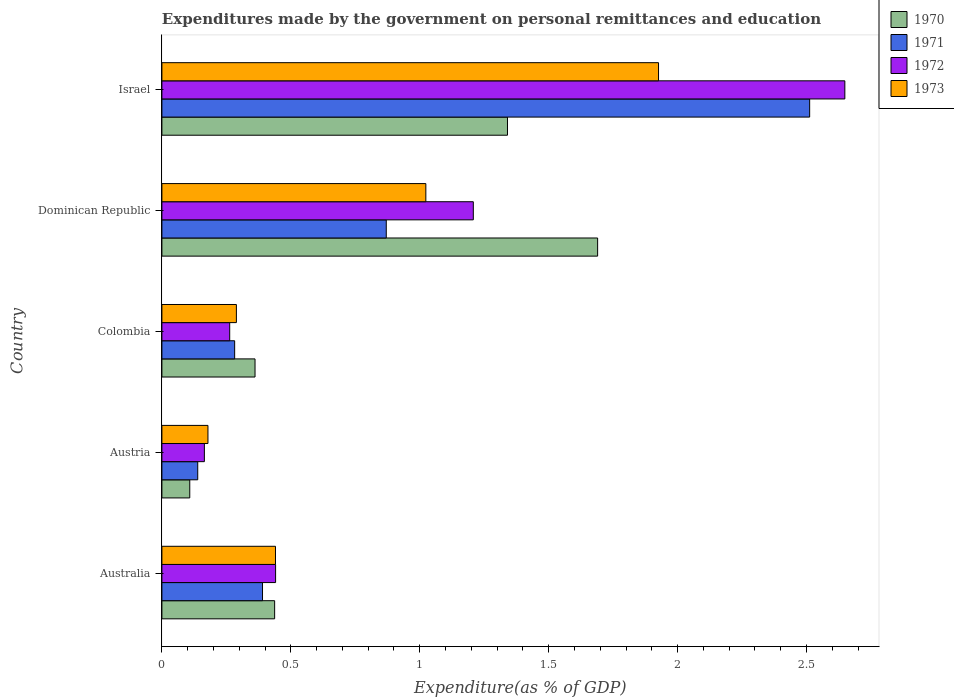How many different coloured bars are there?
Your answer should be very brief. 4. How many groups of bars are there?
Offer a terse response. 5. In how many cases, is the number of bars for a given country not equal to the number of legend labels?
Offer a very short reply. 0. What is the expenditures made by the government on personal remittances and education in 1971 in Australia?
Offer a very short reply. 0.39. Across all countries, what is the maximum expenditures made by the government on personal remittances and education in 1973?
Provide a succinct answer. 1.93. Across all countries, what is the minimum expenditures made by the government on personal remittances and education in 1970?
Give a very brief answer. 0.11. In which country was the expenditures made by the government on personal remittances and education in 1970 maximum?
Give a very brief answer. Dominican Republic. In which country was the expenditures made by the government on personal remittances and education in 1973 minimum?
Offer a terse response. Austria. What is the total expenditures made by the government on personal remittances and education in 1970 in the graph?
Ensure brevity in your answer.  3.94. What is the difference between the expenditures made by the government on personal remittances and education in 1972 in Colombia and that in Israel?
Give a very brief answer. -2.39. What is the difference between the expenditures made by the government on personal remittances and education in 1973 in Colombia and the expenditures made by the government on personal remittances and education in 1970 in Israel?
Your response must be concise. -1.05. What is the average expenditures made by the government on personal remittances and education in 1970 per country?
Offer a terse response. 0.79. What is the difference between the expenditures made by the government on personal remittances and education in 1972 and expenditures made by the government on personal remittances and education in 1973 in Israel?
Offer a very short reply. 0.72. In how many countries, is the expenditures made by the government on personal remittances and education in 1972 greater than 0.2 %?
Provide a short and direct response. 4. What is the ratio of the expenditures made by the government on personal remittances and education in 1971 in Australia to that in Israel?
Offer a very short reply. 0.16. Is the expenditures made by the government on personal remittances and education in 1971 in Australia less than that in Dominican Republic?
Keep it short and to the point. Yes. Is the difference between the expenditures made by the government on personal remittances and education in 1972 in Australia and Colombia greater than the difference between the expenditures made by the government on personal remittances and education in 1973 in Australia and Colombia?
Your response must be concise. Yes. What is the difference between the highest and the second highest expenditures made by the government on personal remittances and education in 1973?
Offer a terse response. 0.9. What is the difference between the highest and the lowest expenditures made by the government on personal remittances and education in 1973?
Offer a very short reply. 1.75. In how many countries, is the expenditures made by the government on personal remittances and education in 1970 greater than the average expenditures made by the government on personal remittances and education in 1970 taken over all countries?
Provide a succinct answer. 2. Is it the case that in every country, the sum of the expenditures made by the government on personal remittances and education in 1973 and expenditures made by the government on personal remittances and education in 1970 is greater than the sum of expenditures made by the government on personal remittances and education in 1972 and expenditures made by the government on personal remittances and education in 1971?
Your response must be concise. No. What does the 3rd bar from the bottom in Dominican Republic represents?
Offer a terse response. 1972. Is it the case that in every country, the sum of the expenditures made by the government on personal remittances and education in 1973 and expenditures made by the government on personal remittances and education in 1972 is greater than the expenditures made by the government on personal remittances and education in 1971?
Keep it short and to the point. Yes. Are the values on the major ticks of X-axis written in scientific E-notation?
Your answer should be compact. No. What is the title of the graph?
Your answer should be compact. Expenditures made by the government on personal remittances and education. Does "1996" appear as one of the legend labels in the graph?
Your answer should be very brief. No. What is the label or title of the X-axis?
Your answer should be very brief. Expenditure(as % of GDP). What is the label or title of the Y-axis?
Provide a short and direct response. Country. What is the Expenditure(as % of GDP) in 1970 in Australia?
Your answer should be compact. 0.44. What is the Expenditure(as % of GDP) in 1971 in Australia?
Offer a terse response. 0.39. What is the Expenditure(as % of GDP) of 1972 in Australia?
Provide a succinct answer. 0.44. What is the Expenditure(as % of GDP) in 1973 in Australia?
Ensure brevity in your answer.  0.44. What is the Expenditure(as % of GDP) of 1970 in Austria?
Keep it short and to the point. 0.11. What is the Expenditure(as % of GDP) of 1971 in Austria?
Offer a very short reply. 0.14. What is the Expenditure(as % of GDP) in 1972 in Austria?
Ensure brevity in your answer.  0.16. What is the Expenditure(as % of GDP) of 1973 in Austria?
Your response must be concise. 0.18. What is the Expenditure(as % of GDP) in 1970 in Colombia?
Provide a short and direct response. 0.36. What is the Expenditure(as % of GDP) in 1971 in Colombia?
Provide a succinct answer. 0.28. What is the Expenditure(as % of GDP) in 1972 in Colombia?
Your answer should be compact. 0.26. What is the Expenditure(as % of GDP) in 1973 in Colombia?
Offer a very short reply. 0.29. What is the Expenditure(as % of GDP) in 1970 in Dominican Republic?
Your answer should be compact. 1.69. What is the Expenditure(as % of GDP) of 1971 in Dominican Republic?
Make the answer very short. 0.87. What is the Expenditure(as % of GDP) in 1972 in Dominican Republic?
Keep it short and to the point. 1.21. What is the Expenditure(as % of GDP) in 1973 in Dominican Republic?
Keep it short and to the point. 1.02. What is the Expenditure(as % of GDP) of 1970 in Israel?
Keep it short and to the point. 1.34. What is the Expenditure(as % of GDP) in 1971 in Israel?
Give a very brief answer. 2.51. What is the Expenditure(as % of GDP) of 1972 in Israel?
Your answer should be very brief. 2.65. What is the Expenditure(as % of GDP) in 1973 in Israel?
Your answer should be very brief. 1.93. Across all countries, what is the maximum Expenditure(as % of GDP) of 1970?
Keep it short and to the point. 1.69. Across all countries, what is the maximum Expenditure(as % of GDP) of 1971?
Give a very brief answer. 2.51. Across all countries, what is the maximum Expenditure(as % of GDP) in 1972?
Offer a very short reply. 2.65. Across all countries, what is the maximum Expenditure(as % of GDP) of 1973?
Ensure brevity in your answer.  1.93. Across all countries, what is the minimum Expenditure(as % of GDP) in 1970?
Offer a very short reply. 0.11. Across all countries, what is the minimum Expenditure(as % of GDP) of 1971?
Offer a terse response. 0.14. Across all countries, what is the minimum Expenditure(as % of GDP) in 1972?
Offer a very short reply. 0.16. Across all countries, what is the minimum Expenditure(as % of GDP) of 1973?
Offer a terse response. 0.18. What is the total Expenditure(as % of GDP) of 1970 in the graph?
Make the answer very short. 3.94. What is the total Expenditure(as % of GDP) in 1971 in the graph?
Your answer should be very brief. 4.19. What is the total Expenditure(as % of GDP) of 1972 in the graph?
Give a very brief answer. 4.72. What is the total Expenditure(as % of GDP) of 1973 in the graph?
Keep it short and to the point. 3.86. What is the difference between the Expenditure(as % of GDP) of 1970 in Australia and that in Austria?
Provide a succinct answer. 0.33. What is the difference between the Expenditure(as % of GDP) in 1971 in Australia and that in Austria?
Offer a terse response. 0.25. What is the difference between the Expenditure(as % of GDP) in 1972 in Australia and that in Austria?
Ensure brevity in your answer.  0.28. What is the difference between the Expenditure(as % of GDP) in 1973 in Australia and that in Austria?
Your answer should be compact. 0.26. What is the difference between the Expenditure(as % of GDP) in 1970 in Australia and that in Colombia?
Make the answer very short. 0.08. What is the difference between the Expenditure(as % of GDP) in 1971 in Australia and that in Colombia?
Ensure brevity in your answer.  0.11. What is the difference between the Expenditure(as % of GDP) in 1972 in Australia and that in Colombia?
Make the answer very short. 0.18. What is the difference between the Expenditure(as % of GDP) of 1973 in Australia and that in Colombia?
Ensure brevity in your answer.  0.15. What is the difference between the Expenditure(as % of GDP) in 1970 in Australia and that in Dominican Republic?
Provide a succinct answer. -1.25. What is the difference between the Expenditure(as % of GDP) of 1971 in Australia and that in Dominican Republic?
Keep it short and to the point. -0.48. What is the difference between the Expenditure(as % of GDP) in 1972 in Australia and that in Dominican Republic?
Provide a succinct answer. -0.77. What is the difference between the Expenditure(as % of GDP) in 1973 in Australia and that in Dominican Republic?
Offer a terse response. -0.58. What is the difference between the Expenditure(as % of GDP) in 1970 in Australia and that in Israel?
Your answer should be very brief. -0.9. What is the difference between the Expenditure(as % of GDP) of 1971 in Australia and that in Israel?
Your answer should be compact. -2.12. What is the difference between the Expenditure(as % of GDP) in 1972 in Australia and that in Israel?
Provide a short and direct response. -2.21. What is the difference between the Expenditure(as % of GDP) in 1973 in Australia and that in Israel?
Give a very brief answer. -1.49. What is the difference between the Expenditure(as % of GDP) in 1970 in Austria and that in Colombia?
Your answer should be compact. -0.25. What is the difference between the Expenditure(as % of GDP) of 1971 in Austria and that in Colombia?
Ensure brevity in your answer.  -0.14. What is the difference between the Expenditure(as % of GDP) in 1972 in Austria and that in Colombia?
Make the answer very short. -0.1. What is the difference between the Expenditure(as % of GDP) of 1973 in Austria and that in Colombia?
Give a very brief answer. -0.11. What is the difference between the Expenditure(as % of GDP) in 1970 in Austria and that in Dominican Republic?
Your answer should be compact. -1.58. What is the difference between the Expenditure(as % of GDP) in 1971 in Austria and that in Dominican Republic?
Offer a very short reply. -0.73. What is the difference between the Expenditure(as % of GDP) of 1972 in Austria and that in Dominican Republic?
Keep it short and to the point. -1.04. What is the difference between the Expenditure(as % of GDP) in 1973 in Austria and that in Dominican Republic?
Give a very brief answer. -0.84. What is the difference between the Expenditure(as % of GDP) of 1970 in Austria and that in Israel?
Your answer should be compact. -1.23. What is the difference between the Expenditure(as % of GDP) of 1971 in Austria and that in Israel?
Keep it short and to the point. -2.37. What is the difference between the Expenditure(as % of GDP) in 1972 in Austria and that in Israel?
Provide a succinct answer. -2.48. What is the difference between the Expenditure(as % of GDP) in 1973 in Austria and that in Israel?
Ensure brevity in your answer.  -1.75. What is the difference between the Expenditure(as % of GDP) of 1970 in Colombia and that in Dominican Republic?
Provide a short and direct response. -1.33. What is the difference between the Expenditure(as % of GDP) of 1971 in Colombia and that in Dominican Republic?
Give a very brief answer. -0.59. What is the difference between the Expenditure(as % of GDP) of 1972 in Colombia and that in Dominican Republic?
Provide a succinct answer. -0.94. What is the difference between the Expenditure(as % of GDP) of 1973 in Colombia and that in Dominican Republic?
Your answer should be very brief. -0.73. What is the difference between the Expenditure(as % of GDP) of 1970 in Colombia and that in Israel?
Offer a terse response. -0.98. What is the difference between the Expenditure(as % of GDP) of 1971 in Colombia and that in Israel?
Provide a succinct answer. -2.23. What is the difference between the Expenditure(as % of GDP) in 1972 in Colombia and that in Israel?
Give a very brief answer. -2.39. What is the difference between the Expenditure(as % of GDP) of 1973 in Colombia and that in Israel?
Provide a succinct answer. -1.64. What is the difference between the Expenditure(as % of GDP) of 1970 in Dominican Republic and that in Israel?
Provide a short and direct response. 0.35. What is the difference between the Expenditure(as % of GDP) of 1971 in Dominican Republic and that in Israel?
Provide a succinct answer. -1.64. What is the difference between the Expenditure(as % of GDP) in 1972 in Dominican Republic and that in Israel?
Provide a succinct answer. -1.44. What is the difference between the Expenditure(as % of GDP) of 1973 in Dominican Republic and that in Israel?
Provide a succinct answer. -0.9. What is the difference between the Expenditure(as % of GDP) of 1970 in Australia and the Expenditure(as % of GDP) of 1971 in Austria?
Make the answer very short. 0.3. What is the difference between the Expenditure(as % of GDP) of 1970 in Australia and the Expenditure(as % of GDP) of 1972 in Austria?
Ensure brevity in your answer.  0.27. What is the difference between the Expenditure(as % of GDP) in 1970 in Australia and the Expenditure(as % of GDP) in 1973 in Austria?
Your answer should be compact. 0.26. What is the difference between the Expenditure(as % of GDP) of 1971 in Australia and the Expenditure(as % of GDP) of 1972 in Austria?
Keep it short and to the point. 0.23. What is the difference between the Expenditure(as % of GDP) in 1971 in Australia and the Expenditure(as % of GDP) in 1973 in Austria?
Ensure brevity in your answer.  0.21. What is the difference between the Expenditure(as % of GDP) of 1972 in Australia and the Expenditure(as % of GDP) of 1973 in Austria?
Your answer should be very brief. 0.26. What is the difference between the Expenditure(as % of GDP) in 1970 in Australia and the Expenditure(as % of GDP) in 1971 in Colombia?
Keep it short and to the point. 0.15. What is the difference between the Expenditure(as % of GDP) in 1970 in Australia and the Expenditure(as % of GDP) in 1972 in Colombia?
Your response must be concise. 0.17. What is the difference between the Expenditure(as % of GDP) in 1970 in Australia and the Expenditure(as % of GDP) in 1973 in Colombia?
Provide a short and direct response. 0.15. What is the difference between the Expenditure(as % of GDP) of 1971 in Australia and the Expenditure(as % of GDP) of 1972 in Colombia?
Provide a succinct answer. 0.13. What is the difference between the Expenditure(as % of GDP) in 1971 in Australia and the Expenditure(as % of GDP) in 1973 in Colombia?
Your response must be concise. 0.1. What is the difference between the Expenditure(as % of GDP) of 1972 in Australia and the Expenditure(as % of GDP) of 1973 in Colombia?
Your answer should be very brief. 0.15. What is the difference between the Expenditure(as % of GDP) in 1970 in Australia and the Expenditure(as % of GDP) in 1971 in Dominican Republic?
Provide a short and direct response. -0.43. What is the difference between the Expenditure(as % of GDP) of 1970 in Australia and the Expenditure(as % of GDP) of 1972 in Dominican Republic?
Provide a short and direct response. -0.77. What is the difference between the Expenditure(as % of GDP) in 1970 in Australia and the Expenditure(as % of GDP) in 1973 in Dominican Republic?
Give a very brief answer. -0.59. What is the difference between the Expenditure(as % of GDP) of 1971 in Australia and the Expenditure(as % of GDP) of 1972 in Dominican Republic?
Your answer should be very brief. -0.82. What is the difference between the Expenditure(as % of GDP) of 1971 in Australia and the Expenditure(as % of GDP) of 1973 in Dominican Republic?
Offer a very short reply. -0.63. What is the difference between the Expenditure(as % of GDP) of 1972 in Australia and the Expenditure(as % of GDP) of 1973 in Dominican Republic?
Provide a succinct answer. -0.58. What is the difference between the Expenditure(as % of GDP) of 1970 in Australia and the Expenditure(as % of GDP) of 1971 in Israel?
Provide a short and direct response. -2.07. What is the difference between the Expenditure(as % of GDP) of 1970 in Australia and the Expenditure(as % of GDP) of 1972 in Israel?
Give a very brief answer. -2.21. What is the difference between the Expenditure(as % of GDP) of 1970 in Australia and the Expenditure(as % of GDP) of 1973 in Israel?
Your answer should be very brief. -1.49. What is the difference between the Expenditure(as % of GDP) of 1971 in Australia and the Expenditure(as % of GDP) of 1972 in Israel?
Your response must be concise. -2.26. What is the difference between the Expenditure(as % of GDP) in 1971 in Australia and the Expenditure(as % of GDP) in 1973 in Israel?
Give a very brief answer. -1.54. What is the difference between the Expenditure(as % of GDP) of 1972 in Australia and the Expenditure(as % of GDP) of 1973 in Israel?
Keep it short and to the point. -1.49. What is the difference between the Expenditure(as % of GDP) in 1970 in Austria and the Expenditure(as % of GDP) in 1971 in Colombia?
Provide a succinct answer. -0.17. What is the difference between the Expenditure(as % of GDP) in 1970 in Austria and the Expenditure(as % of GDP) in 1972 in Colombia?
Provide a succinct answer. -0.15. What is the difference between the Expenditure(as % of GDP) in 1970 in Austria and the Expenditure(as % of GDP) in 1973 in Colombia?
Provide a short and direct response. -0.18. What is the difference between the Expenditure(as % of GDP) in 1971 in Austria and the Expenditure(as % of GDP) in 1972 in Colombia?
Your response must be concise. -0.12. What is the difference between the Expenditure(as % of GDP) in 1971 in Austria and the Expenditure(as % of GDP) in 1973 in Colombia?
Offer a very short reply. -0.15. What is the difference between the Expenditure(as % of GDP) of 1972 in Austria and the Expenditure(as % of GDP) of 1973 in Colombia?
Your response must be concise. -0.12. What is the difference between the Expenditure(as % of GDP) of 1970 in Austria and the Expenditure(as % of GDP) of 1971 in Dominican Republic?
Your response must be concise. -0.76. What is the difference between the Expenditure(as % of GDP) of 1970 in Austria and the Expenditure(as % of GDP) of 1972 in Dominican Republic?
Keep it short and to the point. -1.1. What is the difference between the Expenditure(as % of GDP) in 1970 in Austria and the Expenditure(as % of GDP) in 1973 in Dominican Republic?
Make the answer very short. -0.92. What is the difference between the Expenditure(as % of GDP) of 1971 in Austria and the Expenditure(as % of GDP) of 1972 in Dominican Republic?
Offer a terse response. -1.07. What is the difference between the Expenditure(as % of GDP) of 1971 in Austria and the Expenditure(as % of GDP) of 1973 in Dominican Republic?
Make the answer very short. -0.88. What is the difference between the Expenditure(as % of GDP) in 1972 in Austria and the Expenditure(as % of GDP) in 1973 in Dominican Republic?
Ensure brevity in your answer.  -0.86. What is the difference between the Expenditure(as % of GDP) in 1970 in Austria and the Expenditure(as % of GDP) in 1971 in Israel?
Your answer should be very brief. -2.4. What is the difference between the Expenditure(as % of GDP) of 1970 in Austria and the Expenditure(as % of GDP) of 1972 in Israel?
Provide a short and direct response. -2.54. What is the difference between the Expenditure(as % of GDP) of 1970 in Austria and the Expenditure(as % of GDP) of 1973 in Israel?
Your answer should be compact. -1.82. What is the difference between the Expenditure(as % of GDP) in 1971 in Austria and the Expenditure(as % of GDP) in 1972 in Israel?
Your response must be concise. -2.51. What is the difference between the Expenditure(as % of GDP) of 1971 in Austria and the Expenditure(as % of GDP) of 1973 in Israel?
Keep it short and to the point. -1.79. What is the difference between the Expenditure(as % of GDP) of 1972 in Austria and the Expenditure(as % of GDP) of 1973 in Israel?
Provide a succinct answer. -1.76. What is the difference between the Expenditure(as % of GDP) of 1970 in Colombia and the Expenditure(as % of GDP) of 1971 in Dominican Republic?
Offer a terse response. -0.51. What is the difference between the Expenditure(as % of GDP) of 1970 in Colombia and the Expenditure(as % of GDP) of 1972 in Dominican Republic?
Provide a short and direct response. -0.85. What is the difference between the Expenditure(as % of GDP) in 1970 in Colombia and the Expenditure(as % of GDP) in 1973 in Dominican Republic?
Provide a short and direct response. -0.66. What is the difference between the Expenditure(as % of GDP) of 1971 in Colombia and the Expenditure(as % of GDP) of 1972 in Dominican Republic?
Your response must be concise. -0.93. What is the difference between the Expenditure(as % of GDP) in 1971 in Colombia and the Expenditure(as % of GDP) in 1973 in Dominican Republic?
Your answer should be very brief. -0.74. What is the difference between the Expenditure(as % of GDP) of 1972 in Colombia and the Expenditure(as % of GDP) of 1973 in Dominican Republic?
Make the answer very short. -0.76. What is the difference between the Expenditure(as % of GDP) of 1970 in Colombia and the Expenditure(as % of GDP) of 1971 in Israel?
Provide a succinct answer. -2.15. What is the difference between the Expenditure(as % of GDP) in 1970 in Colombia and the Expenditure(as % of GDP) in 1972 in Israel?
Keep it short and to the point. -2.29. What is the difference between the Expenditure(as % of GDP) in 1970 in Colombia and the Expenditure(as % of GDP) in 1973 in Israel?
Your answer should be very brief. -1.56. What is the difference between the Expenditure(as % of GDP) in 1971 in Colombia and the Expenditure(as % of GDP) in 1972 in Israel?
Make the answer very short. -2.37. What is the difference between the Expenditure(as % of GDP) in 1971 in Colombia and the Expenditure(as % of GDP) in 1973 in Israel?
Offer a terse response. -1.64. What is the difference between the Expenditure(as % of GDP) of 1972 in Colombia and the Expenditure(as % of GDP) of 1973 in Israel?
Your answer should be compact. -1.66. What is the difference between the Expenditure(as % of GDP) in 1970 in Dominican Republic and the Expenditure(as % of GDP) in 1971 in Israel?
Offer a terse response. -0.82. What is the difference between the Expenditure(as % of GDP) in 1970 in Dominican Republic and the Expenditure(as % of GDP) in 1972 in Israel?
Give a very brief answer. -0.96. What is the difference between the Expenditure(as % of GDP) of 1970 in Dominican Republic and the Expenditure(as % of GDP) of 1973 in Israel?
Provide a short and direct response. -0.24. What is the difference between the Expenditure(as % of GDP) in 1971 in Dominican Republic and the Expenditure(as % of GDP) in 1972 in Israel?
Give a very brief answer. -1.78. What is the difference between the Expenditure(as % of GDP) in 1971 in Dominican Republic and the Expenditure(as % of GDP) in 1973 in Israel?
Offer a very short reply. -1.06. What is the difference between the Expenditure(as % of GDP) in 1972 in Dominican Republic and the Expenditure(as % of GDP) in 1973 in Israel?
Offer a very short reply. -0.72. What is the average Expenditure(as % of GDP) in 1970 per country?
Provide a short and direct response. 0.79. What is the average Expenditure(as % of GDP) of 1971 per country?
Provide a short and direct response. 0.84. What is the average Expenditure(as % of GDP) of 1972 per country?
Provide a short and direct response. 0.94. What is the average Expenditure(as % of GDP) of 1973 per country?
Your answer should be compact. 0.77. What is the difference between the Expenditure(as % of GDP) in 1970 and Expenditure(as % of GDP) in 1971 in Australia?
Provide a succinct answer. 0.05. What is the difference between the Expenditure(as % of GDP) of 1970 and Expenditure(as % of GDP) of 1972 in Australia?
Your answer should be very brief. -0. What is the difference between the Expenditure(as % of GDP) in 1970 and Expenditure(as % of GDP) in 1973 in Australia?
Provide a short and direct response. -0. What is the difference between the Expenditure(as % of GDP) in 1971 and Expenditure(as % of GDP) in 1972 in Australia?
Give a very brief answer. -0.05. What is the difference between the Expenditure(as % of GDP) in 1971 and Expenditure(as % of GDP) in 1973 in Australia?
Offer a very short reply. -0.05. What is the difference between the Expenditure(as % of GDP) in 1972 and Expenditure(as % of GDP) in 1973 in Australia?
Keep it short and to the point. 0. What is the difference between the Expenditure(as % of GDP) in 1970 and Expenditure(as % of GDP) in 1971 in Austria?
Keep it short and to the point. -0.03. What is the difference between the Expenditure(as % of GDP) of 1970 and Expenditure(as % of GDP) of 1972 in Austria?
Give a very brief answer. -0.06. What is the difference between the Expenditure(as % of GDP) in 1970 and Expenditure(as % of GDP) in 1973 in Austria?
Offer a very short reply. -0.07. What is the difference between the Expenditure(as % of GDP) of 1971 and Expenditure(as % of GDP) of 1972 in Austria?
Keep it short and to the point. -0.03. What is the difference between the Expenditure(as % of GDP) of 1971 and Expenditure(as % of GDP) of 1973 in Austria?
Ensure brevity in your answer.  -0.04. What is the difference between the Expenditure(as % of GDP) in 1972 and Expenditure(as % of GDP) in 1973 in Austria?
Provide a succinct answer. -0.01. What is the difference between the Expenditure(as % of GDP) of 1970 and Expenditure(as % of GDP) of 1971 in Colombia?
Provide a succinct answer. 0.08. What is the difference between the Expenditure(as % of GDP) of 1970 and Expenditure(as % of GDP) of 1972 in Colombia?
Offer a very short reply. 0.1. What is the difference between the Expenditure(as % of GDP) in 1970 and Expenditure(as % of GDP) in 1973 in Colombia?
Keep it short and to the point. 0.07. What is the difference between the Expenditure(as % of GDP) in 1971 and Expenditure(as % of GDP) in 1972 in Colombia?
Your answer should be compact. 0.02. What is the difference between the Expenditure(as % of GDP) in 1971 and Expenditure(as % of GDP) in 1973 in Colombia?
Ensure brevity in your answer.  -0.01. What is the difference between the Expenditure(as % of GDP) in 1972 and Expenditure(as % of GDP) in 1973 in Colombia?
Provide a succinct answer. -0.03. What is the difference between the Expenditure(as % of GDP) of 1970 and Expenditure(as % of GDP) of 1971 in Dominican Republic?
Provide a short and direct response. 0.82. What is the difference between the Expenditure(as % of GDP) in 1970 and Expenditure(as % of GDP) in 1972 in Dominican Republic?
Your answer should be very brief. 0.48. What is the difference between the Expenditure(as % of GDP) in 1970 and Expenditure(as % of GDP) in 1973 in Dominican Republic?
Give a very brief answer. 0.67. What is the difference between the Expenditure(as % of GDP) of 1971 and Expenditure(as % of GDP) of 1972 in Dominican Republic?
Ensure brevity in your answer.  -0.34. What is the difference between the Expenditure(as % of GDP) in 1971 and Expenditure(as % of GDP) in 1973 in Dominican Republic?
Offer a terse response. -0.15. What is the difference between the Expenditure(as % of GDP) in 1972 and Expenditure(as % of GDP) in 1973 in Dominican Republic?
Provide a succinct answer. 0.18. What is the difference between the Expenditure(as % of GDP) in 1970 and Expenditure(as % of GDP) in 1971 in Israel?
Give a very brief answer. -1.17. What is the difference between the Expenditure(as % of GDP) of 1970 and Expenditure(as % of GDP) of 1972 in Israel?
Give a very brief answer. -1.31. What is the difference between the Expenditure(as % of GDP) of 1970 and Expenditure(as % of GDP) of 1973 in Israel?
Keep it short and to the point. -0.59. What is the difference between the Expenditure(as % of GDP) of 1971 and Expenditure(as % of GDP) of 1972 in Israel?
Your answer should be compact. -0.14. What is the difference between the Expenditure(as % of GDP) of 1971 and Expenditure(as % of GDP) of 1973 in Israel?
Give a very brief answer. 0.59. What is the difference between the Expenditure(as % of GDP) of 1972 and Expenditure(as % of GDP) of 1973 in Israel?
Ensure brevity in your answer.  0.72. What is the ratio of the Expenditure(as % of GDP) in 1970 in Australia to that in Austria?
Keep it short and to the point. 4.04. What is the ratio of the Expenditure(as % of GDP) of 1971 in Australia to that in Austria?
Offer a very short reply. 2.81. What is the ratio of the Expenditure(as % of GDP) of 1972 in Australia to that in Austria?
Provide a short and direct response. 2.68. What is the ratio of the Expenditure(as % of GDP) in 1973 in Australia to that in Austria?
Ensure brevity in your answer.  2.47. What is the ratio of the Expenditure(as % of GDP) in 1970 in Australia to that in Colombia?
Keep it short and to the point. 1.21. What is the ratio of the Expenditure(as % of GDP) in 1971 in Australia to that in Colombia?
Provide a succinct answer. 1.38. What is the ratio of the Expenditure(as % of GDP) of 1972 in Australia to that in Colombia?
Your answer should be very brief. 1.68. What is the ratio of the Expenditure(as % of GDP) of 1973 in Australia to that in Colombia?
Ensure brevity in your answer.  1.52. What is the ratio of the Expenditure(as % of GDP) in 1970 in Australia to that in Dominican Republic?
Your answer should be very brief. 0.26. What is the ratio of the Expenditure(as % of GDP) of 1971 in Australia to that in Dominican Republic?
Keep it short and to the point. 0.45. What is the ratio of the Expenditure(as % of GDP) of 1972 in Australia to that in Dominican Republic?
Your answer should be compact. 0.37. What is the ratio of the Expenditure(as % of GDP) in 1973 in Australia to that in Dominican Republic?
Keep it short and to the point. 0.43. What is the ratio of the Expenditure(as % of GDP) in 1970 in Australia to that in Israel?
Offer a very short reply. 0.33. What is the ratio of the Expenditure(as % of GDP) in 1971 in Australia to that in Israel?
Make the answer very short. 0.16. What is the ratio of the Expenditure(as % of GDP) in 1972 in Australia to that in Israel?
Make the answer very short. 0.17. What is the ratio of the Expenditure(as % of GDP) in 1973 in Australia to that in Israel?
Make the answer very short. 0.23. What is the ratio of the Expenditure(as % of GDP) in 1970 in Austria to that in Colombia?
Give a very brief answer. 0.3. What is the ratio of the Expenditure(as % of GDP) in 1971 in Austria to that in Colombia?
Give a very brief answer. 0.49. What is the ratio of the Expenditure(as % of GDP) of 1972 in Austria to that in Colombia?
Ensure brevity in your answer.  0.63. What is the ratio of the Expenditure(as % of GDP) of 1973 in Austria to that in Colombia?
Keep it short and to the point. 0.62. What is the ratio of the Expenditure(as % of GDP) in 1970 in Austria to that in Dominican Republic?
Your answer should be very brief. 0.06. What is the ratio of the Expenditure(as % of GDP) of 1971 in Austria to that in Dominican Republic?
Your response must be concise. 0.16. What is the ratio of the Expenditure(as % of GDP) in 1972 in Austria to that in Dominican Republic?
Keep it short and to the point. 0.14. What is the ratio of the Expenditure(as % of GDP) in 1973 in Austria to that in Dominican Republic?
Offer a very short reply. 0.17. What is the ratio of the Expenditure(as % of GDP) of 1970 in Austria to that in Israel?
Offer a very short reply. 0.08. What is the ratio of the Expenditure(as % of GDP) in 1971 in Austria to that in Israel?
Offer a terse response. 0.06. What is the ratio of the Expenditure(as % of GDP) of 1972 in Austria to that in Israel?
Provide a succinct answer. 0.06. What is the ratio of the Expenditure(as % of GDP) of 1973 in Austria to that in Israel?
Your answer should be very brief. 0.09. What is the ratio of the Expenditure(as % of GDP) of 1970 in Colombia to that in Dominican Republic?
Your answer should be compact. 0.21. What is the ratio of the Expenditure(as % of GDP) of 1971 in Colombia to that in Dominican Republic?
Give a very brief answer. 0.32. What is the ratio of the Expenditure(as % of GDP) of 1972 in Colombia to that in Dominican Republic?
Provide a short and direct response. 0.22. What is the ratio of the Expenditure(as % of GDP) in 1973 in Colombia to that in Dominican Republic?
Your answer should be very brief. 0.28. What is the ratio of the Expenditure(as % of GDP) in 1970 in Colombia to that in Israel?
Ensure brevity in your answer.  0.27. What is the ratio of the Expenditure(as % of GDP) of 1971 in Colombia to that in Israel?
Your answer should be very brief. 0.11. What is the ratio of the Expenditure(as % of GDP) in 1972 in Colombia to that in Israel?
Your answer should be very brief. 0.1. What is the ratio of the Expenditure(as % of GDP) in 1970 in Dominican Republic to that in Israel?
Your response must be concise. 1.26. What is the ratio of the Expenditure(as % of GDP) of 1971 in Dominican Republic to that in Israel?
Give a very brief answer. 0.35. What is the ratio of the Expenditure(as % of GDP) of 1972 in Dominican Republic to that in Israel?
Offer a very short reply. 0.46. What is the ratio of the Expenditure(as % of GDP) in 1973 in Dominican Republic to that in Israel?
Your response must be concise. 0.53. What is the difference between the highest and the second highest Expenditure(as % of GDP) of 1970?
Ensure brevity in your answer.  0.35. What is the difference between the highest and the second highest Expenditure(as % of GDP) in 1971?
Provide a succinct answer. 1.64. What is the difference between the highest and the second highest Expenditure(as % of GDP) in 1972?
Your answer should be very brief. 1.44. What is the difference between the highest and the second highest Expenditure(as % of GDP) in 1973?
Your answer should be very brief. 0.9. What is the difference between the highest and the lowest Expenditure(as % of GDP) in 1970?
Provide a short and direct response. 1.58. What is the difference between the highest and the lowest Expenditure(as % of GDP) in 1971?
Make the answer very short. 2.37. What is the difference between the highest and the lowest Expenditure(as % of GDP) of 1972?
Ensure brevity in your answer.  2.48. What is the difference between the highest and the lowest Expenditure(as % of GDP) in 1973?
Keep it short and to the point. 1.75. 